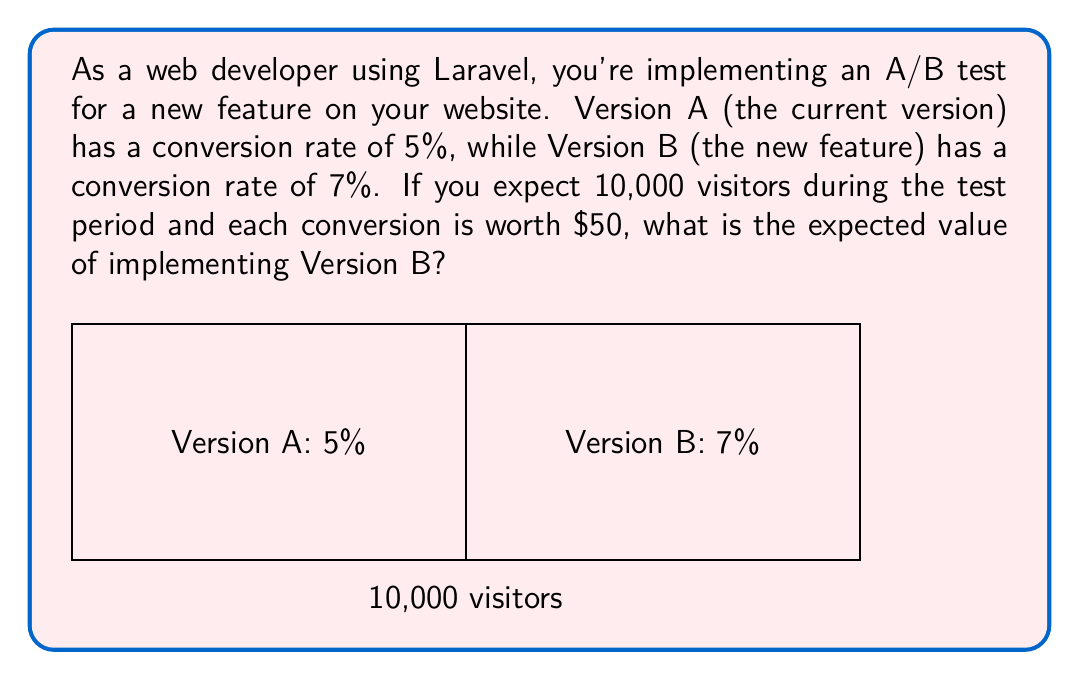What is the answer to this math problem? To calculate the expected value of implementing Version B, we need to follow these steps:

1. Calculate the difference in conversion rates:
   $\Delta CR = CR_B - CR_A = 7\% - 5\% = 2\%$

2. Calculate the additional conversions:
   $\text{Additional Conversions} = \Delta CR \times \text{Total Visitors}$
   $= 2\% \times 10,000 = 0.02 \times 10,000 = 200$

3. Calculate the value of additional conversions:
   $\text{Value} = \text{Additional Conversions} \times \text{Value per Conversion}$
   $= 200 \times \$50 = \$10,000$

Therefore, the expected value of implementing Version B is $10,000.

In Laravel Excel, you could use this calculation to generate reports on A/B test results, helping to make data-driven decisions for your web development projects.
Answer: $10,000 